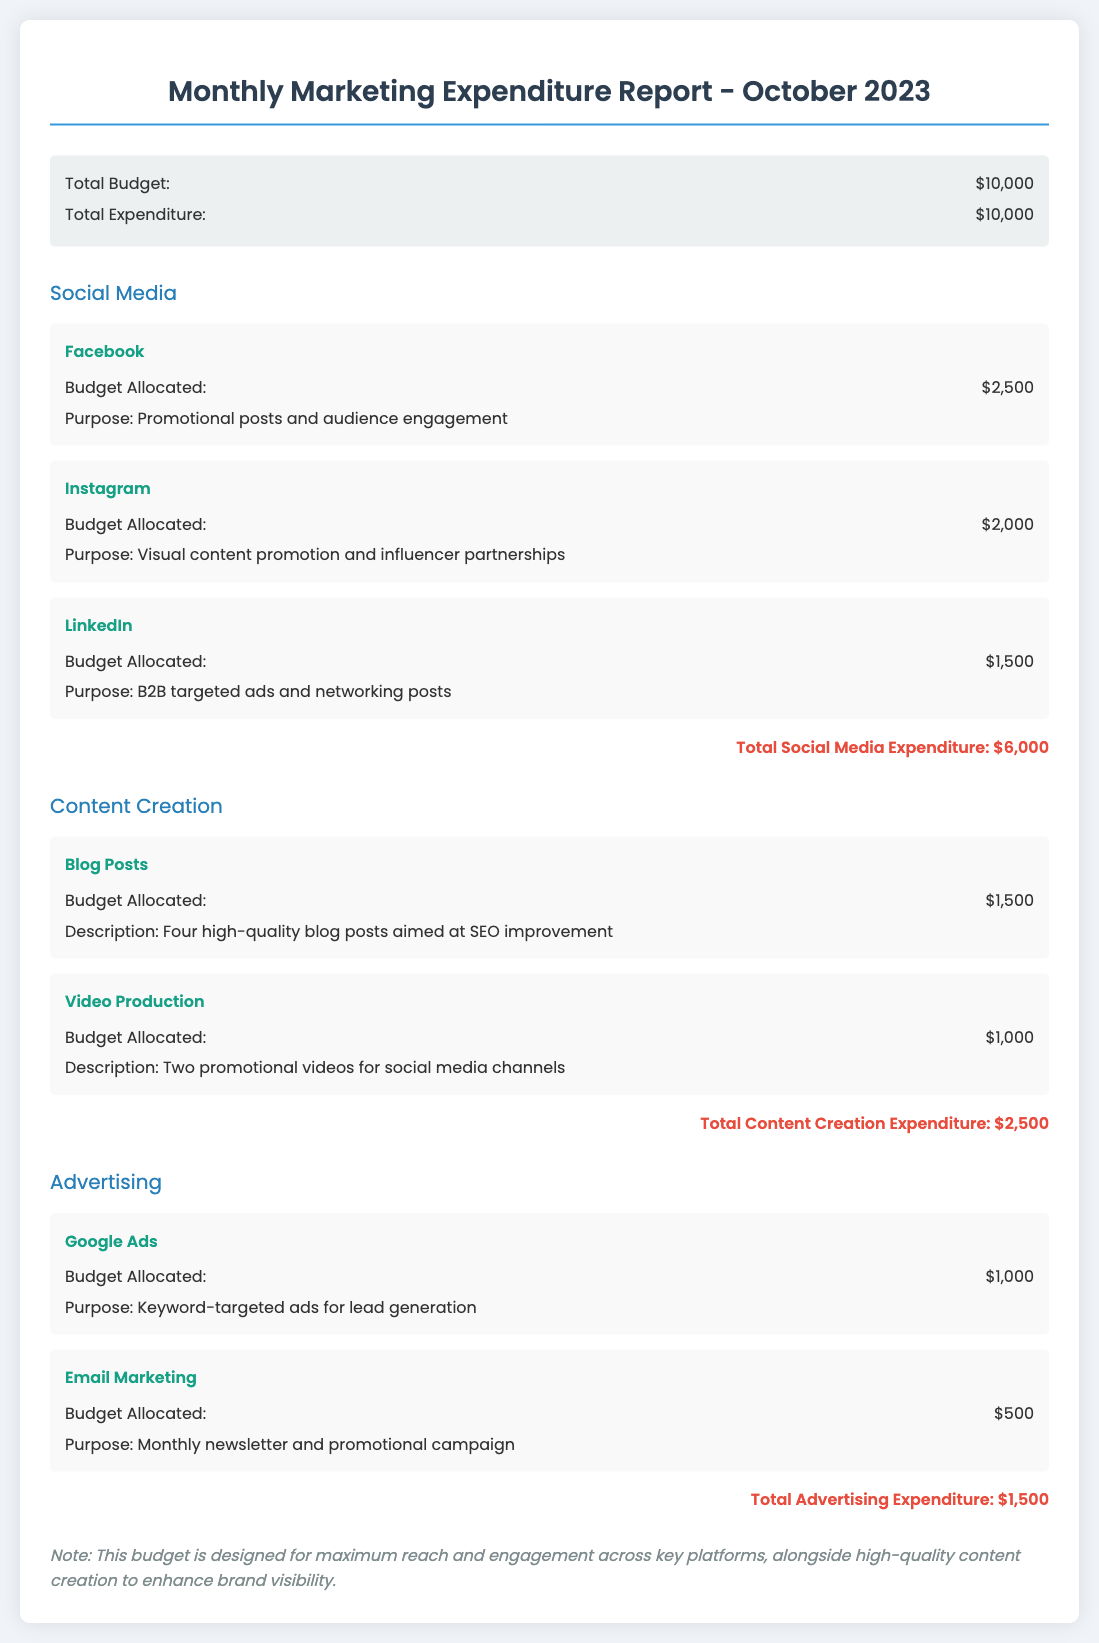What is the total budget? The total budget is stated in the summary section of the document.
Answer: $10,000 What is the total expenditure? The total expenditure is also found in the summary section of the document and matches the total budget.
Answer: $10,000 How much is allocated for Facebook? The budget allocated for Facebook is specified under the Social Media category.
Answer: $2,500 What is the purpose of the Instagram expenditure? The document describes the purpose related to Instagram under the Social Media category.
Answer: Visual content promotion and influencer partnerships What is the total expenditure on content creation? The total expenditure for content creation is summarized at the end of that category.
Answer: $2,500 How much is allocated for Google Ads? The budget for Google Ads is detailed in the Advertising category.
Answer: $1,000 Which platform has the lowest budget allocation? The platform with the lowest budget allocation is identified under the Advertising category.
Answer: Email Marketing What percentage of the total budget is spent on social media? This requires calculating the percentage based on total expenditure on social media against total budget.
Answer: 60% What are the key areas of expenditure in the budget? The document lists specific categories of expenditure: Social Media, Content Creation, and Advertising.
Answer: Social Media, Content Creation, Advertising What is the note about in the document? The note provides additional context on the budget's design objective.
Answer: Maximum reach and engagement across key platforms 